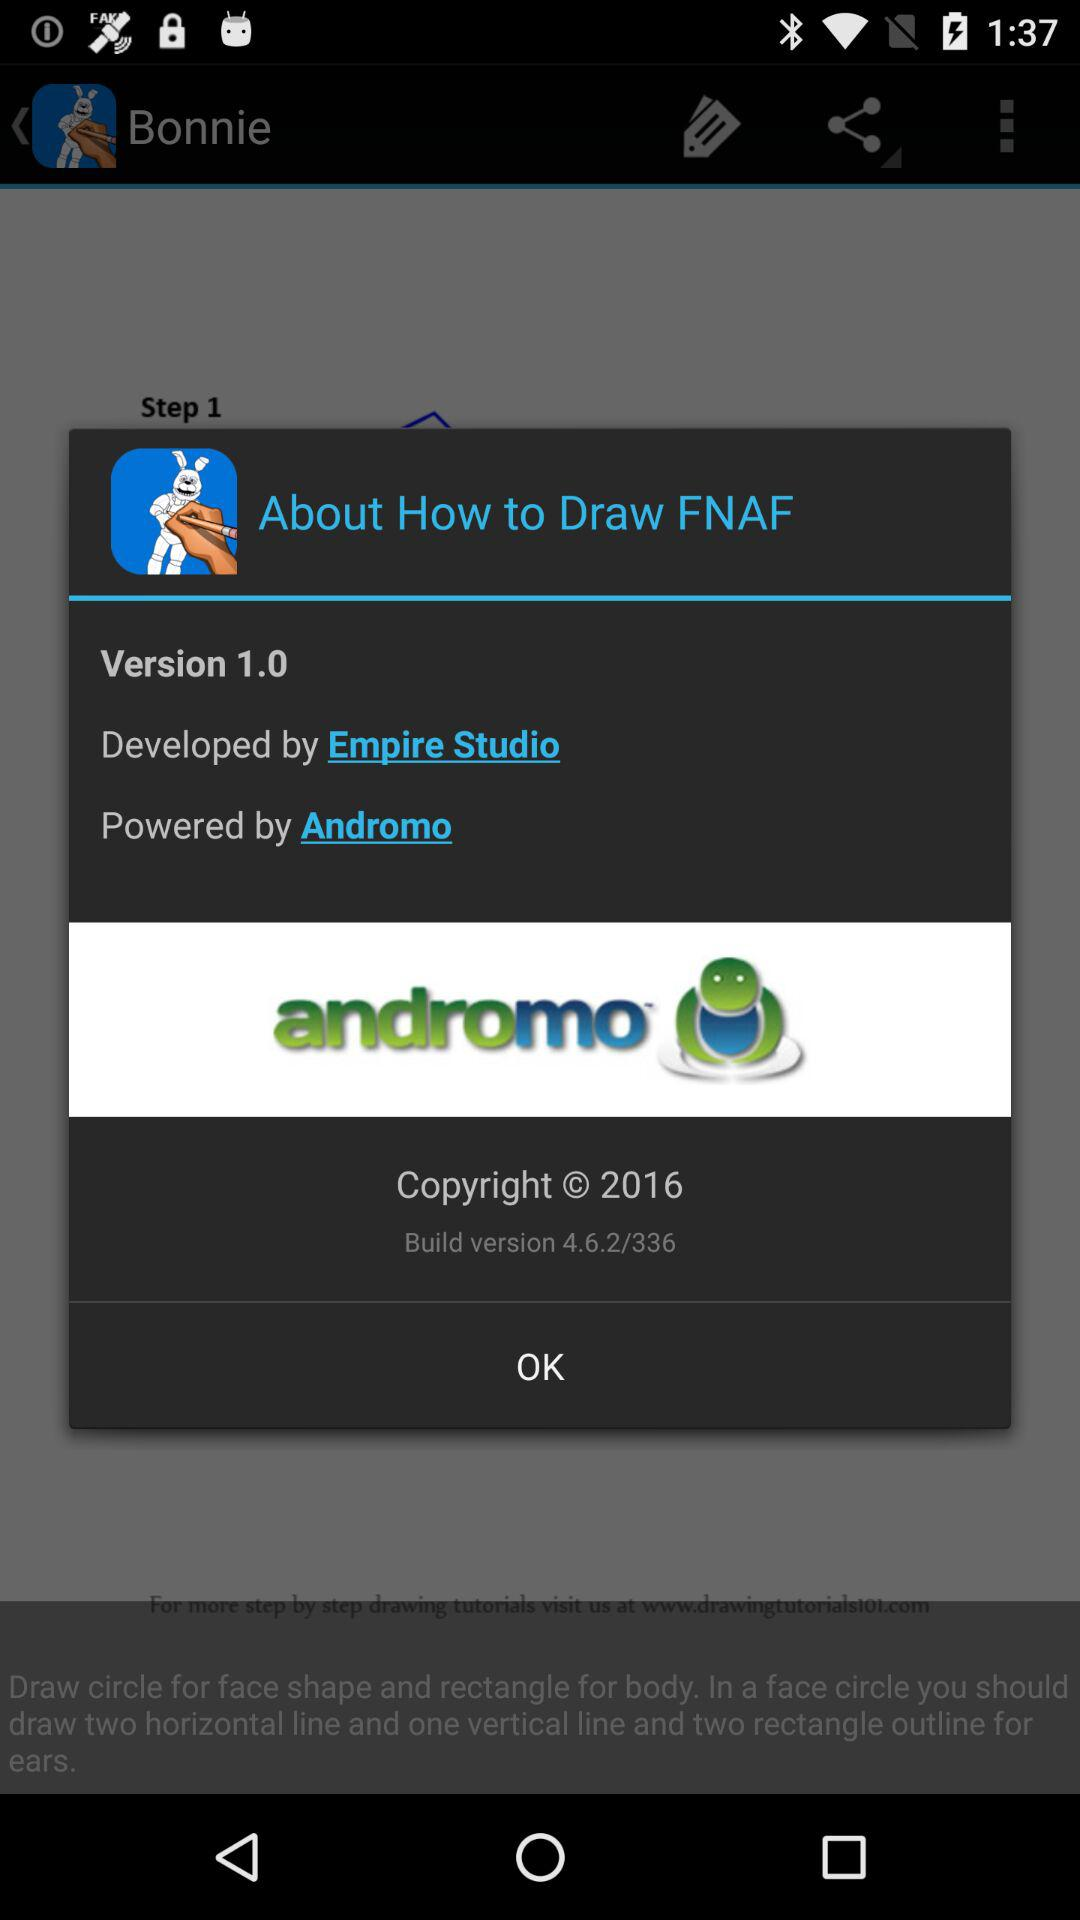Which application version is used? The used application version is 1.0. 